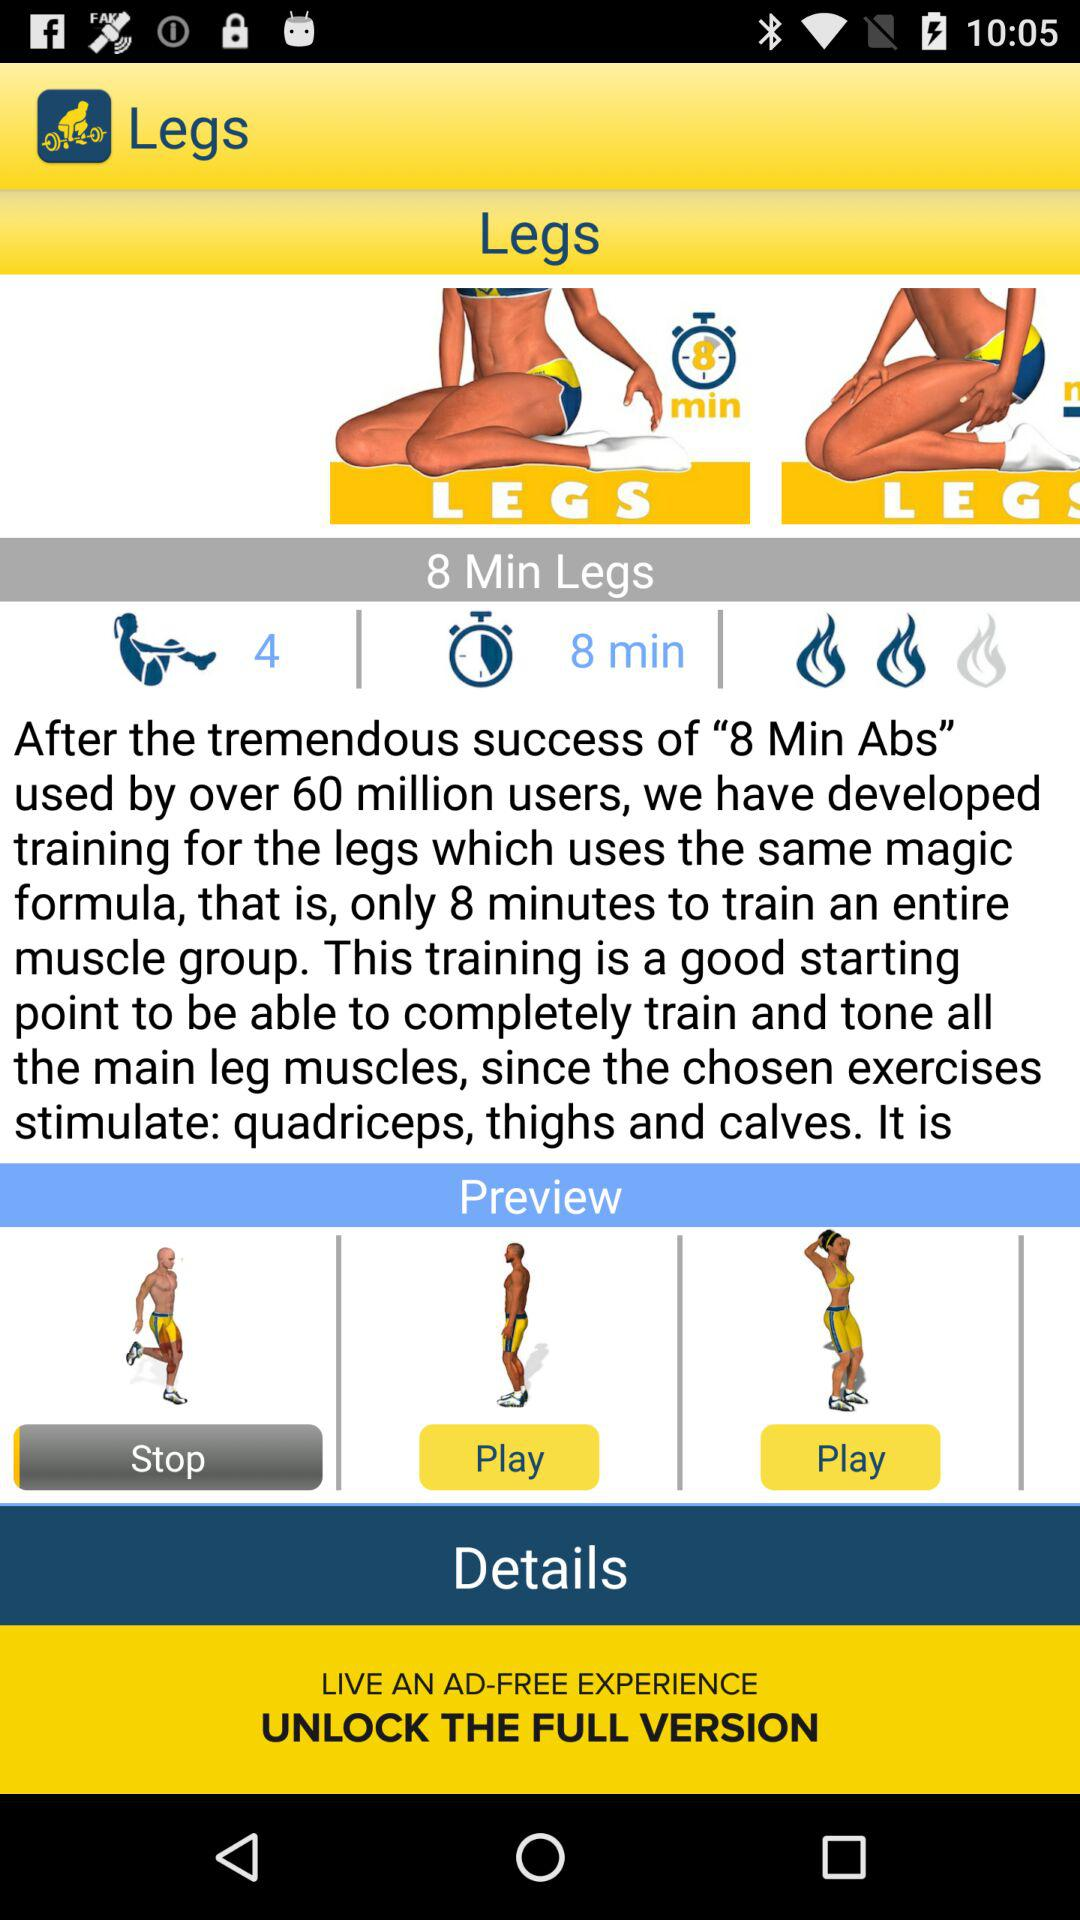What is the time duration of one round of the leg exercise? The time duration is 8 minutes. 